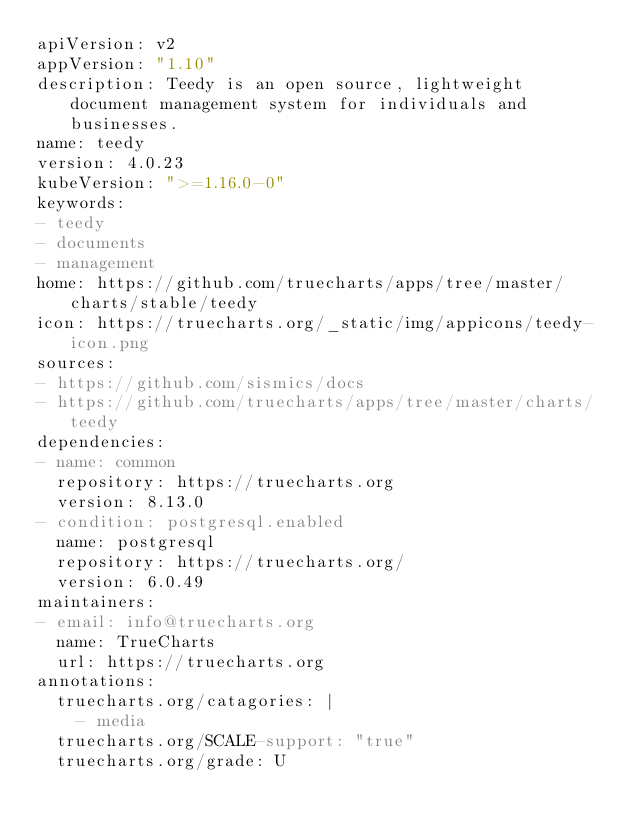Convert code to text. <code><loc_0><loc_0><loc_500><loc_500><_YAML_>apiVersion: v2
appVersion: "1.10"
description: Teedy is an open source, lightweight document management system for individuals and businesses.
name: teedy
version: 4.0.23
kubeVersion: ">=1.16.0-0"
keywords:
- teedy
- documents
- management
home: https://github.com/truecharts/apps/tree/master/charts/stable/teedy
icon: https://truecharts.org/_static/img/appicons/teedy-icon.png
sources:
- https://github.com/sismics/docs
- https://github.com/truecharts/apps/tree/master/charts/teedy
dependencies:
- name: common
  repository: https://truecharts.org
  version: 8.13.0
- condition: postgresql.enabled
  name: postgresql
  repository: https://truecharts.org/
  version: 6.0.49
maintainers:
- email: info@truecharts.org
  name: TrueCharts
  url: https://truecharts.org
annotations:
  truecharts.org/catagories: |
    - media
  truecharts.org/SCALE-support: "true"
  truecharts.org/grade: U
</code> 